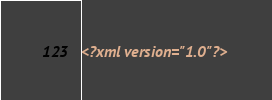<code> <loc_0><loc_0><loc_500><loc_500><_XML_><?xml version="1.0"?></code> 